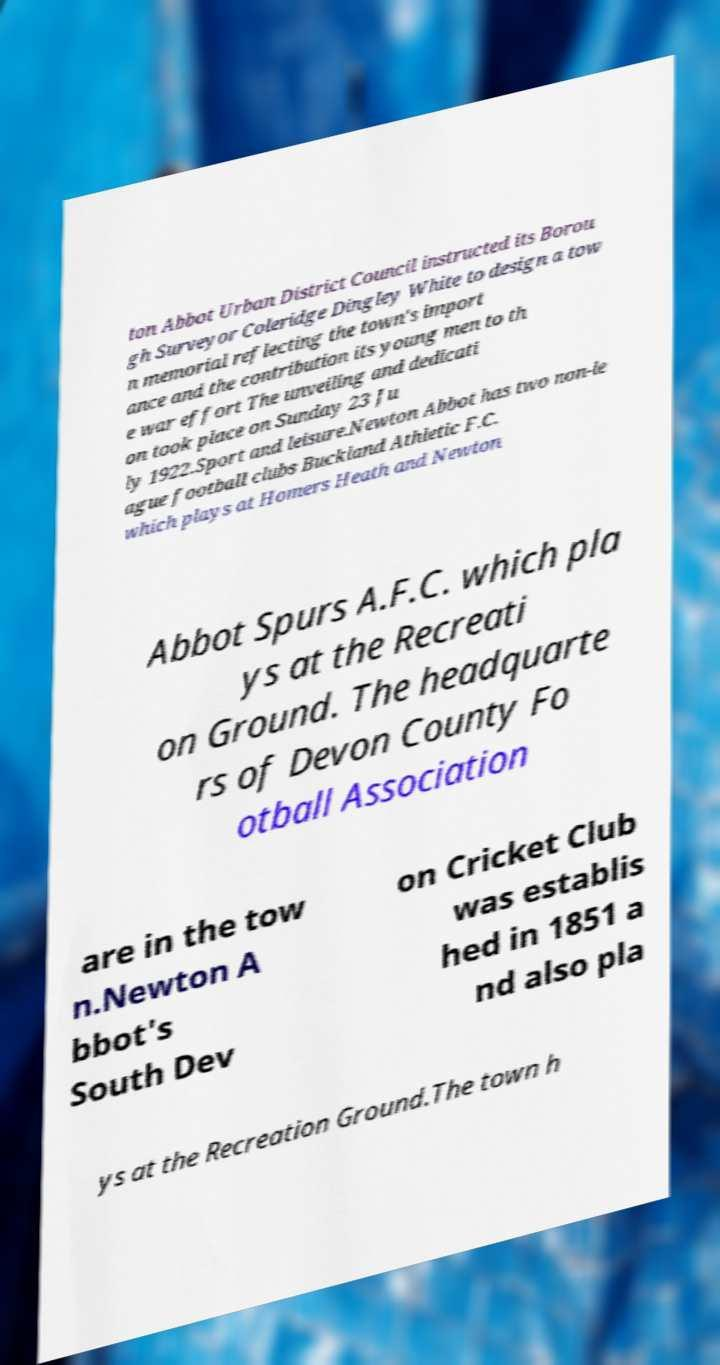Can you accurately transcribe the text from the provided image for me? ton Abbot Urban District Council instructed its Borou gh Surveyor Coleridge Dingley White to design a tow n memorial reflecting the town's import ance and the contribution its young men to th e war effort The unveiling and dedicati on took place on Sunday 23 Ju ly 1922.Sport and leisure.Newton Abbot has two non-le ague football clubs Buckland Athletic F.C. which plays at Homers Heath and Newton Abbot Spurs A.F.C. which pla ys at the Recreati on Ground. The headquarte rs of Devon County Fo otball Association are in the tow n.Newton A bbot's South Dev on Cricket Club was establis hed in 1851 a nd also pla ys at the Recreation Ground.The town h 